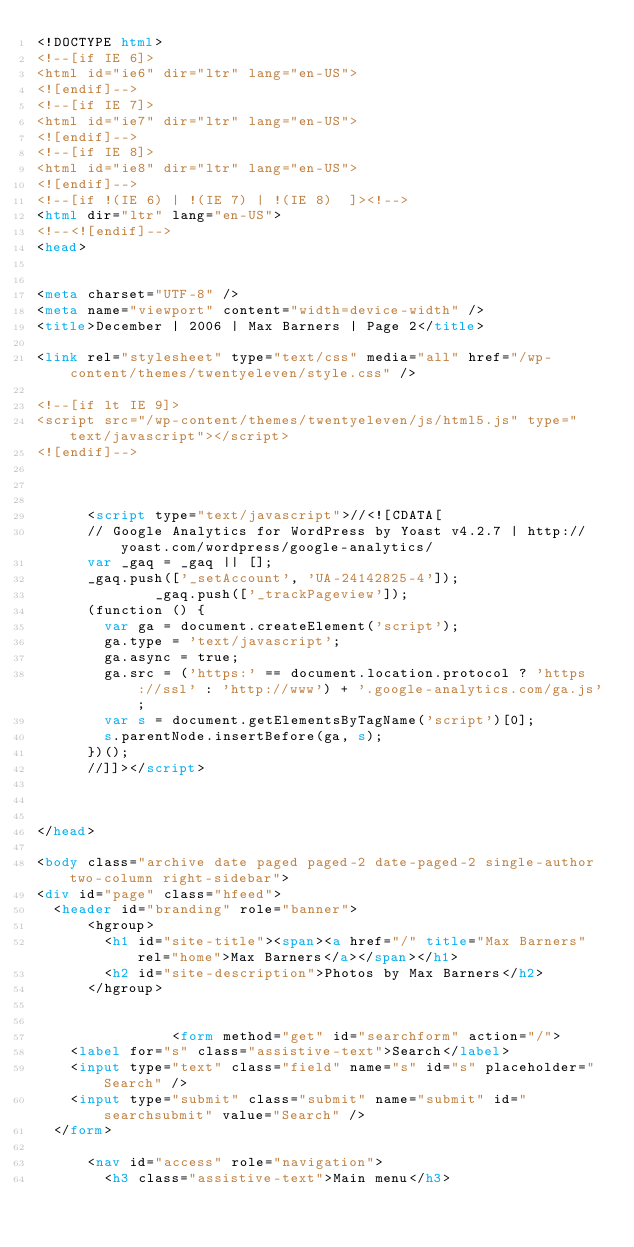Convert code to text. <code><loc_0><loc_0><loc_500><loc_500><_HTML_><!DOCTYPE html>
<!--[if IE 6]>
<html id="ie6" dir="ltr" lang="en-US">
<![endif]-->
<!--[if IE 7]>
<html id="ie7" dir="ltr" lang="en-US">
<![endif]-->
<!--[if IE 8]>
<html id="ie8" dir="ltr" lang="en-US">
<![endif]-->
<!--[if !(IE 6) | !(IE 7) | !(IE 8)  ]><!-->
<html dir="ltr" lang="en-US">
<!--<![endif]-->
<head>


<meta charset="UTF-8" />
<meta name="viewport" content="width=device-width" />
<title>December | 2006 | Max Barners | Page 2</title>

<link rel="stylesheet" type="text/css" media="all" href="/wp-content/themes/twentyeleven/style.css" />

<!--[if lt IE 9]>
<script src="/wp-content/themes/twentyeleven/js/html5.js" type="text/javascript"></script>
<![endif]-->



			<script type="text/javascript">//<![CDATA[
			// Google Analytics for WordPress by Yoast v4.2.7 | http://yoast.com/wordpress/google-analytics/
			var _gaq = _gaq || [];
			_gaq.push(['_setAccount', 'UA-24142825-4']);
							_gaq.push(['_trackPageview']);
			(function () {
				var ga = document.createElement('script');
				ga.type = 'text/javascript';
				ga.async = true;
				ga.src = ('https:' == document.location.protocol ? 'https://ssl' : 'http://www') + '.google-analytics.com/ga.js';
				var s = document.getElementsByTagName('script')[0];
				s.parentNode.insertBefore(ga, s);
			})();
			//]]></script>
			
 

</head>

<body class="archive date paged paged-2 date-paged-2 single-author two-column right-sidebar">
<div id="page" class="hfeed">
	<header id="branding" role="banner">
			<hgroup>
				<h1 id="site-title"><span><a href="/" title="Max Barners" rel="home">Max Barners</a></span></h1>
				<h2 id="site-description">Photos by Max Barners</h2>
			</hgroup>

			
								<form method="get" id="searchform" action="/">
		<label for="s" class="assistive-text">Search</label>
		<input type="text" class="field" name="s" id="s" placeholder="Search" />
		<input type="submit" class="submit" name="submit" id="searchsubmit" value="Search" />
	</form>
			
			<nav id="access" role="navigation">
				<h3 class="assistive-text">Main menu</h3></code> 